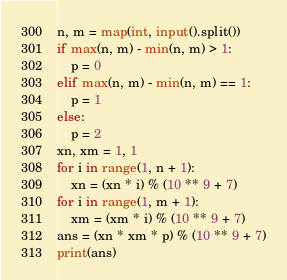Convert code to text. <code><loc_0><loc_0><loc_500><loc_500><_Python_>n, m = map(int, input().split())
if max(n, m) - min(n, m) > 1:
    p = 0
elif max(n, m) - min(n, m) == 1:
    p = 1
else:
    p = 2
xn, xm = 1, 1
for i in range(1, n + 1):
    xn = (xn * i) % (10 ** 9 + 7)
for i in range(1, m + 1):
    xm = (xm * i) % (10 ** 9 + 7)
ans = (xn * xm * p) % (10 ** 9 + 7)
print(ans)</code> 